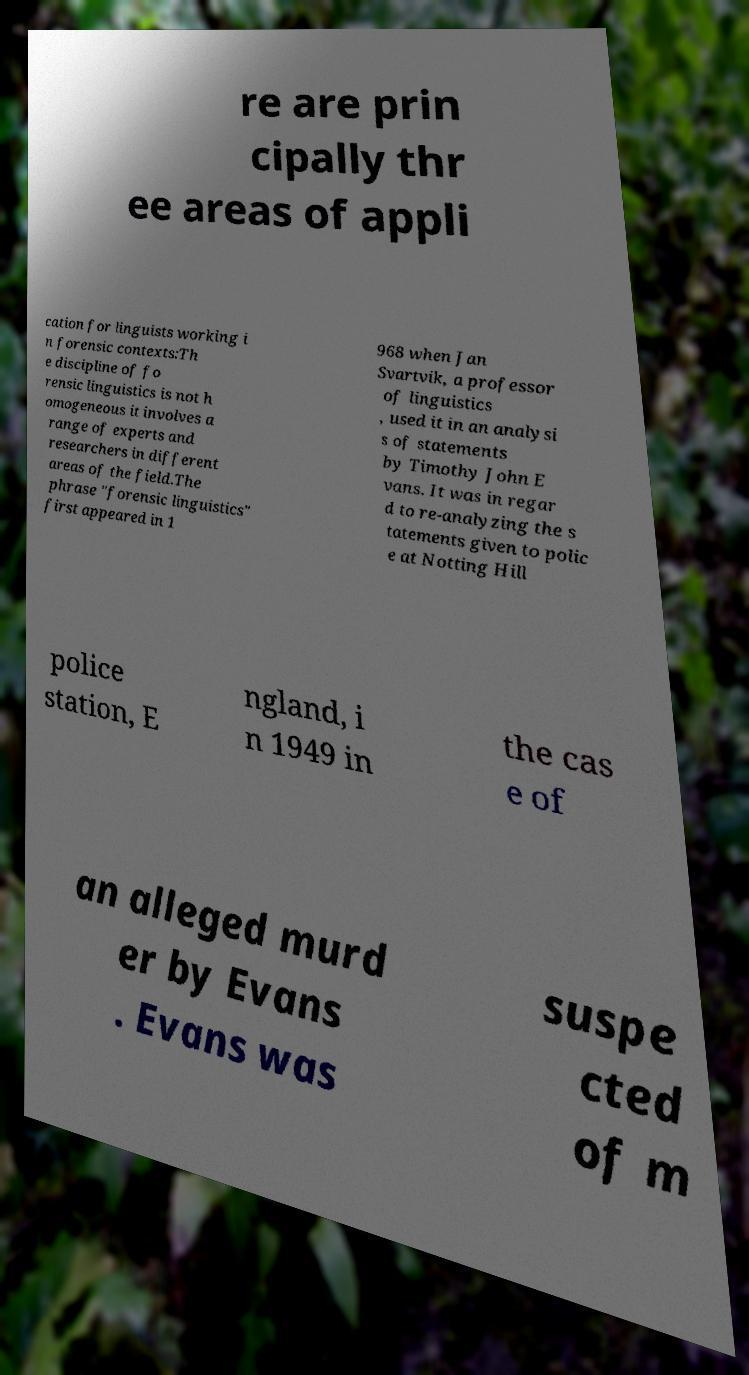Please identify and transcribe the text found in this image. re are prin cipally thr ee areas of appli cation for linguists working i n forensic contexts:Th e discipline of fo rensic linguistics is not h omogeneous it involves a range of experts and researchers in different areas of the field.The phrase "forensic linguistics" first appeared in 1 968 when Jan Svartvik, a professor of linguistics , used it in an analysi s of statements by Timothy John E vans. It was in regar d to re-analyzing the s tatements given to polic e at Notting Hill police station, E ngland, i n 1949 in the cas e of an alleged murd er by Evans . Evans was suspe cted of m 